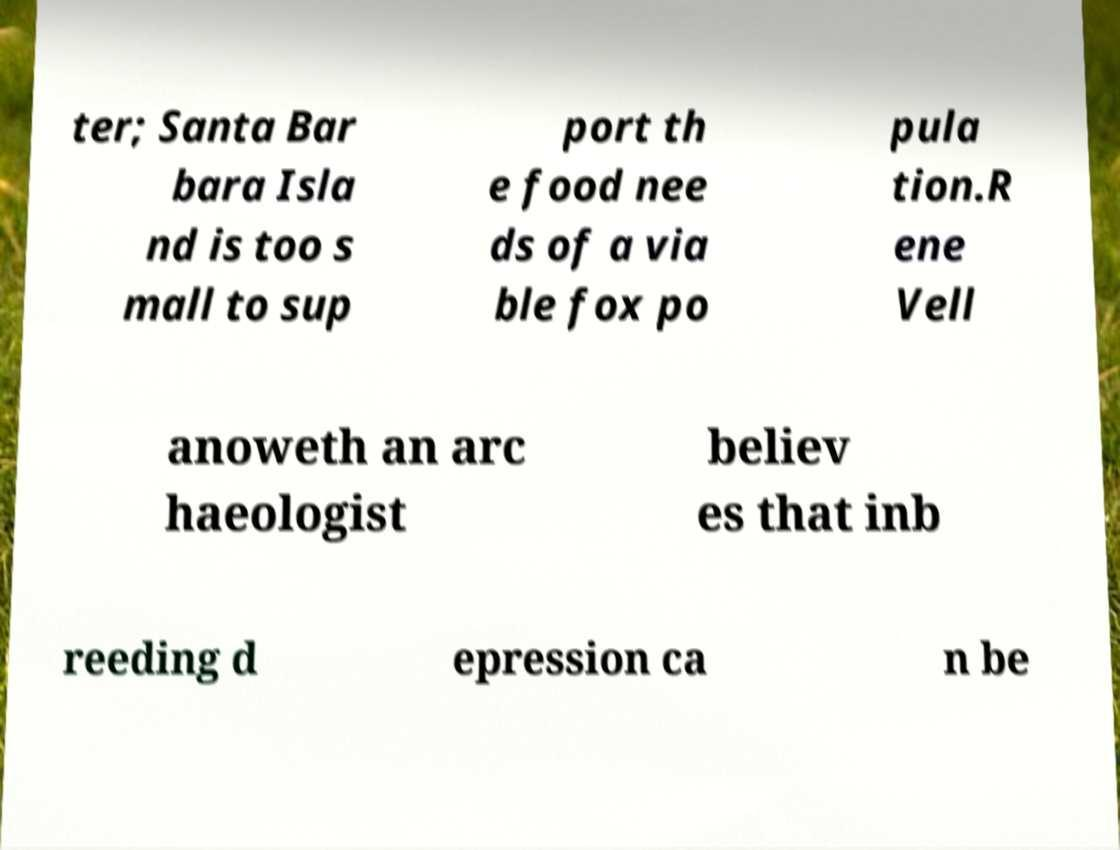Could you assist in decoding the text presented in this image and type it out clearly? ter; Santa Bar bara Isla nd is too s mall to sup port th e food nee ds of a via ble fox po pula tion.R ene Vell anoweth an arc haeologist believ es that inb reeding d epression ca n be 